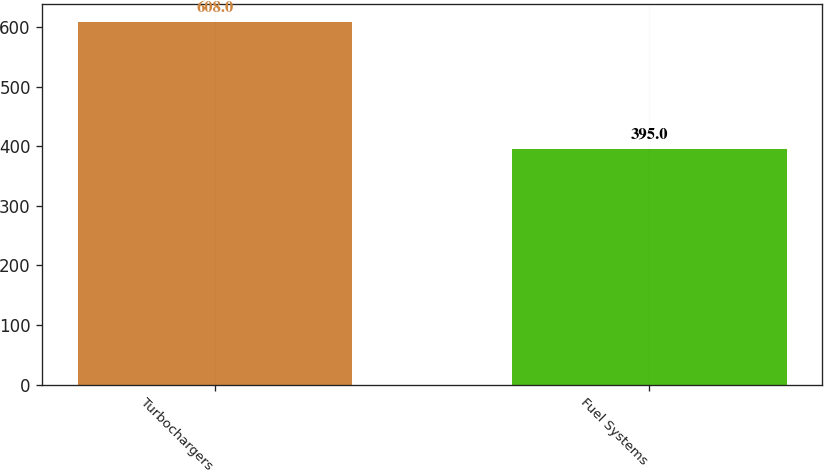Convert chart to OTSL. <chart><loc_0><loc_0><loc_500><loc_500><bar_chart><fcel>Turbochargers<fcel>Fuel Systems<nl><fcel>608<fcel>395<nl></chart> 